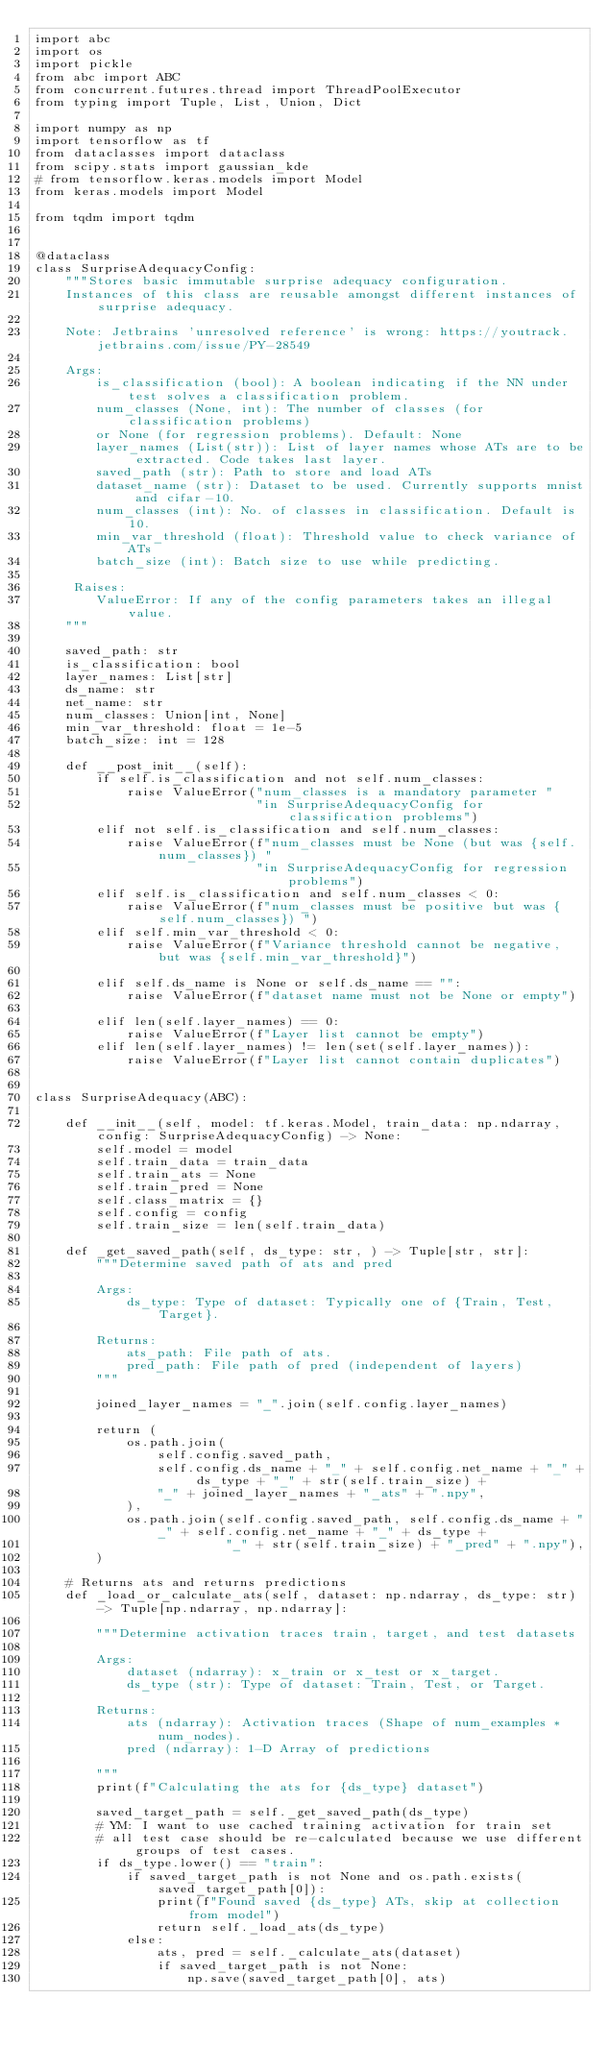Convert code to text. <code><loc_0><loc_0><loc_500><loc_500><_Python_>import abc
import os
import pickle
from abc import ABC
from concurrent.futures.thread import ThreadPoolExecutor
from typing import Tuple, List, Union, Dict

import numpy as np
import tensorflow as tf
from dataclasses import dataclass
from scipy.stats import gaussian_kde
# from tensorflow.keras.models import Model
from keras.models import Model

from tqdm import tqdm


@dataclass
class SurpriseAdequacyConfig:
    """Stores basic immutable surprise adequacy configuration.
    Instances of this class are reusable amongst different instances of surprise adequacy.

    Note: Jetbrains 'unresolved reference' is wrong: https://youtrack.jetbrains.com/issue/PY-28549

    Args:
        is_classification (bool): A boolean indicating if the NN under test solves a classification problem.
        num_classes (None, int): The number of classes (for classification problems)
        or None (for regression problems). Default: None
        layer_names (List(str)): List of layer names whose ATs are to be extracted. Code takes last layer.
        saved_path (str): Path to store and load ATs
        dataset_name (str): Dataset to be used. Currently supports mnist and cifar-10.
        num_classes (int): No. of classes in classification. Default is 10.
        min_var_threshold (float): Threshold value to check variance of ATs
        batch_size (int): Batch size to use while predicting.

     Raises:
        ValueError: If any of the config parameters takes an illegal value.
    """

    saved_path: str
    is_classification: bool
    layer_names: List[str]
    ds_name: str
    net_name: str
    num_classes: Union[int, None]
    min_var_threshold: float = 1e-5
    batch_size: int = 128

    def __post_init__(self):
        if self.is_classification and not self.num_classes:
            raise ValueError("num_classes is a mandatory parameter "
                             "in SurpriseAdequacyConfig for classification problems")
        elif not self.is_classification and self.num_classes:
            raise ValueError(f"num_classes must be None (but was {self.num_classes}) "
                             "in SurpriseAdequacyConfig for regression problems")
        elif self.is_classification and self.num_classes < 0:
            raise ValueError(f"num_classes must be positive but was {self.num_classes}) ")
        elif self.min_var_threshold < 0:
            raise ValueError(f"Variance threshold cannot be negative, but was {self.min_var_threshold}")

        elif self.ds_name is None or self.ds_name == "":
            raise ValueError(f"dataset name must not be None or empty")

        elif len(self.layer_names) == 0:
            raise ValueError(f"Layer list cannot be empty")
        elif len(self.layer_names) != len(set(self.layer_names)):
            raise ValueError(f"Layer list cannot contain duplicates")


class SurpriseAdequacy(ABC):

    def __init__(self, model: tf.keras.Model, train_data: np.ndarray, config: SurpriseAdequacyConfig) -> None:
        self.model = model
        self.train_data = train_data
        self.train_ats = None
        self.train_pred = None
        self.class_matrix = {}
        self.config = config
        self.train_size = len(self.train_data)

    def _get_saved_path(self, ds_type: str, ) -> Tuple[str, str]:
        """Determine saved path of ats and pred

        Args:
            ds_type: Type of dataset: Typically one of {Train, Test, Target}.

        Returns:
            ats_path: File path of ats.
            pred_path: File path of pred (independent of layers)
        """

        joined_layer_names = "_".join(self.config.layer_names)

        return (
            os.path.join(
                self.config.saved_path,
                self.config.ds_name + "_" + self.config.net_name + "_" + ds_type + "_" + str(self.train_size) +
                "_" + joined_layer_names + "_ats" + ".npy",
            ),
            os.path.join(self.config.saved_path, self.config.ds_name + "_" + self.config.net_name + "_" + ds_type +
                         "_" + str(self.train_size) + "_pred" + ".npy"),
        )

    # Returns ats and returns predictions
    def _load_or_calculate_ats(self, dataset: np.ndarray, ds_type: str) -> Tuple[np.ndarray, np.ndarray]:

        """Determine activation traces train, target, and test datasets

        Args:
            dataset (ndarray): x_train or x_test or x_target.
            ds_type (str): Type of dataset: Train, Test, or Target.

        Returns:
            ats (ndarray): Activation traces (Shape of num_examples * num_nodes).
            pred (ndarray): 1-D Array of predictions

        """
        print(f"Calculating the ats for {ds_type} dataset")

        saved_target_path = self._get_saved_path(ds_type)
        # YM: I want to use cached training activation for train set
        # all test case should be re-calculated because we use different groups of test cases.
        if ds_type.lower() == "train":
            if saved_target_path is not None and os.path.exists(saved_target_path[0]):
                print(f"Found saved {ds_type} ATs, skip at collection from model")
                return self._load_ats(ds_type)
            else:
                ats, pred = self._calculate_ats(dataset)
                if saved_target_path is not None:
                    np.save(saved_target_path[0], ats)</code> 